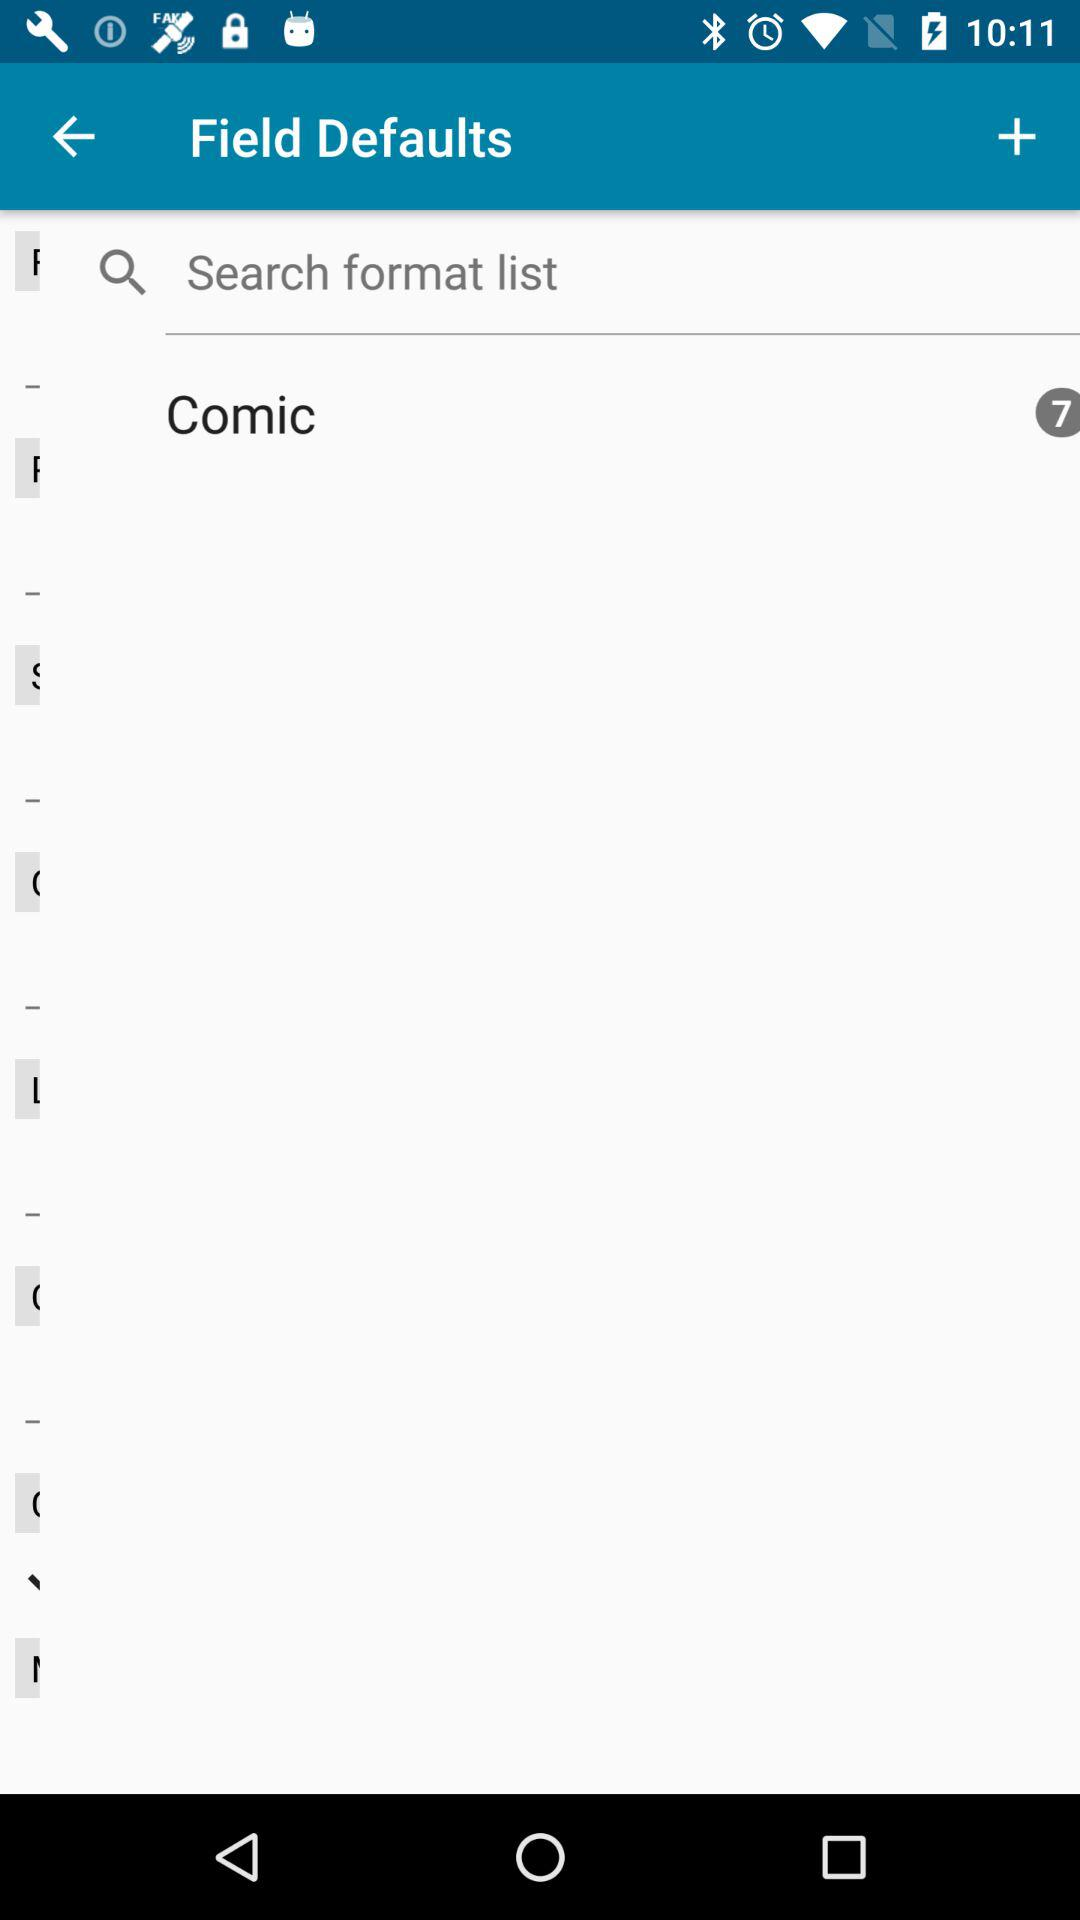What is the count for "Comic"? The count for "Comic" is 7. 